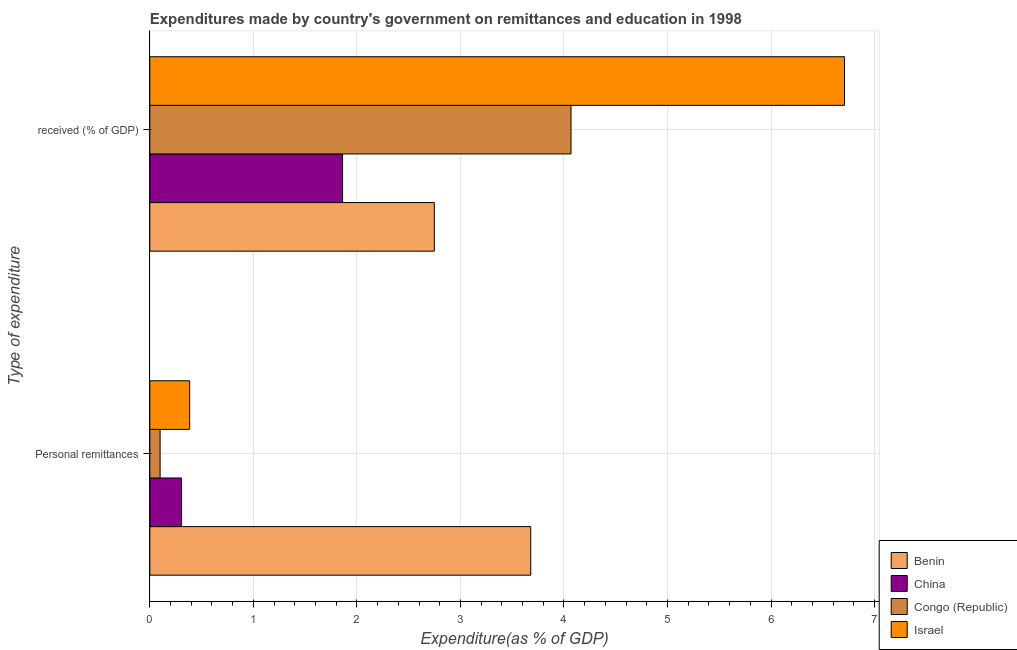How many groups of bars are there?
Ensure brevity in your answer.  2. How many bars are there on the 2nd tick from the top?
Your response must be concise. 4. How many bars are there on the 2nd tick from the bottom?
Provide a short and direct response. 4. What is the label of the 1st group of bars from the top?
Your response must be concise.  received (% of GDP). What is the expenditure in personal remittances in China?
Make the answer very short. 0.31. Across all countries, what is the maximum expenditure in education?
Your answer should be very brief. 6.71. Across all countries, what is the minimum expenditure in personal remittances?
Your answer should be compact. 0.1. In which country was the expenditure in personal remittances minimum?
Ensure brevity in your answer.  Congo (Republic). What is the total expenditure in education in the graph?
Offer a terse response. 15.39. What is the difference between the expenditure in personal remittances in Congo (Republic) and that in Benin?
Provide a succinct answer. -3.58. What is the difference between the expenditure in personal remittances in Congo (Republic) and the expenditure in education in China?
Offer a terse response. -1.76. What is the average expenditure in education per country?
Your answer should be compact. 3.85. What is the difference between the expenditure in personal remittances and expenditure in education in Benin?
Give a very brief answer. 0.93. In how many countries, is the expenditure in personal remittances greater than 1 %?
Keep it short and to the point. 1. What is the ratio of the expenditure in education in China to that in Benin?
Provide a succinct answer. 0.68. What does the 3rd bar from the bottom in  received (% of GDP) represents?
Keep it short and to the point. Congo (Republic). How many bars are there?
Provide a succinct answer. 8. Are all the bars in the graph horizontal?
Offer a very short reply. Yes. Does the graph contain grids?
Your answer should be compact. Yes. Where does the legend appear in the graph?
Your answer should be very brief. Bottom right. How many legend labels are there?
Your answer should be very brief. 4. How are the legend labels stacked?
Provide a short and direct response. Vertical. What is the title of the graph?
Make the answer very short. Expenditures made by country's government on remittances and education in 1998. What is the label or title of the X-axis?
Your answer should be very brief. Expenditure(as % of GDP). What is the label or title of the Y-axis?
Your answer should be very brief. Type of expenditure. What is the Expenditure(as % of GDP) of Benin in Personal remittances?
Offer a terse response. 3.68. What is the Expenditure(as % of GDP) in China in Personal remittances?
Offer a very short reply. 0.31. What is the Expenditure(as % of GDP) of Congo (Republic) in Personal remittances?
Keep it short and to the point. 0.1. What is the Expenditure(as % of GDP) of Israel in Personal remittances?
Make the answer very short. 0.38. What is the Expenditure(as % of GDP) of Benin in  received (% of GDP)?
Keep it short and to the point. 2.75. What is the Expenditure(as % of GDP) of China in  received (% of GDP)?
Ensure brevity in your answer.  1.86. What is the Expenditure(as % of GDP) of Congo (Republic) in  received (% of GDP)?
Keep it short and to the point. 4.07. What is the Expenditure(as % of GDP) in Israel in  received (% of GDP)?
Your response must be concise. 6.71. Across all Type of expenditure, what is the maximum Expenditure(as % of GDP) in Benin?
Provide a succinct answer. 3.68. Across all Type of expenditure, what is the maximum Expenditure(as % of GDP) in China?
Provide a short and direct response. 1.86. Across all Type of expenditure, what is the maximum Expenditure(as % of GDP) in Congo (Republic)?
Your response must be concise. 4.07. Across all Type of expenditure, what is the maximum Expenditure(as % of GDP) in Israel?
Offer a terse response. 6.71. Across all Type of expenditure, what is the minimum Expenditure(as % of GDP) of Benin?
Provide a succinct answer. 2.75. Across all Type of expenditure, what is the minimum Expenditure(as % of GDP) of China?
Make the answer very short. 0.31. Across all Type of expenditure, what is the minimum Expenditure(as % of GDP) of Congo (Republic)?
Your answer should be very brief. 0.1. Across all Type of expenditure, what is the minimum Expenditure(as % of GDP) in Israel?
Ensure brevity in your answer.  0.38. What is the total Expenditure(as % of GDP) of Benin in the graph?
Offer a very short reply. 6.43. What is the total Expenditure(as % of GDP) of China in the graph?
Provide a short and direct response. 2.17. What is the total Expenditure(as % of GDP) in Congo (Republic) in the graph?
Your response must be concise. 4.17. What is the total Expenditure(as % of GDP) of Israel in the graph?
Provide a succinct answer. 7.09. What is the difference between the Expenditure(as % of GDP) in Benin in Personal remittances and that in  received (% of GDP)?
Keep it short and to the point. 0.93. What is the difference between the Expenditure(as % of GDP) of China in Personal remittances and that in  received (% of GDP)?
Provide a succinct answer. -1.56. What is the difference between the Expenditure(as % of GDP) of Congo (Republic) in Personal remittances and that in  received (% of GDP)?
Your answer should be compact. -3.97. What is the difference between the Expenditure(as % of GDP) in Israel in Personal remittances and that in  received (% of GDP)?
Your answer should be compact. -6.32. What is the difference between the Expenditure(as % of GDP) of Benin in Personal remittances and the Expenditure(as % of GDP) of China in  received (% of GDP)?
Your response must be concise. 1.82. What is the difference between the Expenditure(as % of GDP) of Benin in Personal remittances and the Expenditure(as % of GDP) of Congo (Republic) in  received (% of GDP)?
Make the answer very short. -0.39. What is the difference between the Expenditure(as % of GDP) of Benin in Personal remittances and the Expenditure(as % of GDP) of Israel in  received (% of GDP)?
Your answer should be very brief. -3.03. What is the difference between the Expenditure(as % of GDP) of China in Personal remittances and the Expenditure(as % of GDP) of Congo (Republic) in  received (% of GDP)?
Your answer should be compact. -3.76. What is the difference between the Expenditure(as % of GDP) of China in Personal remittances and the Expenditure(as % of GDP) of Israel in  received (% of GDP)?
Keep it short and to the point. -6.4. What is the difference between the Expenditure(as % of GDP) of Congo (Republic) in Personal remittances and the Expenditure(as % of GDP) of Israel in  received (% of GDP)?
Your answer should be very brief. -6.61. What is the average Expenditure(as % of GDP) in Benin per Type of expenditure?
Offer a terse response. 3.21. What is the average Expenditure(as % of GDP) of China per Type of expenditure?
Provide a succinct answer. 1.08. What is the average Expenditure(as % of GDP) in Congo (Republic) per Type of expenditure?
Ensure brevity in your answer.  2.08. What is the average Expenditure(as % of GDP) in Israel per Type of expenditure?
Offer a terse response. 3.55. What is the difference between the Expenditure(as % of GDP) in Benin and Expenditure(as % of GDP) in China in Personal remittances?
Make the answer very short. 3.37. What is the difference between the Expenditure(as % of GDP) in Benin and Expenditure(as % of GDP) in Congo (Republic) in Personal remittances?
Your answer should be very brief. 3.58. What is the difference between the Expenditure(as % of GDP) in Benin and Expenditure(as % of GDP) in Israel in Personal remittances?
Give a very brief answer. 3.29. What is the difference between the Expenditure(as % of GDP) of China and Expenditure(as % of GDP) of Congo (Republic) in Personal remittances?
Your answer should be very brief. 0.21. What is the difference between the Expenditure(as % of GDP) in China and Expenditure(as % of GDP) in Israel in Personal remittances?
Provide a short and direct response. -0.08. What is the difference between the Expenditure(as % of GDP) in Congo (Republic) and Expenditure(as % of GDP) in Israel in Personal remittances?
Keep it short and to the point. -0.29. What is the difference between the Expenditure(as % of GDP) in Benin and Expenditure(as % of GDP) in China in  received (% of GDP)?
Ensure brevity in your answer.  0.89. What is the difference between the Expenditure(as % of GDP) of Benin and Expenditure(as % of GDP) of Congo (Republic) in  received (% of GDP)?
Provide a short and direct response. -1.32. What is the difference between the Expenditure(as % of GDP) of Benin and Expenditure(as % of GDP) of Israel in  received (% of GDP)?
Make the answer very short. -3.96. What is the difference between the Expenditure(as % of GDP) of China and Expenditure(as % of GDP) of Congo (Republic) in  received (% of GDP)?
Offer a very short reply. -2.21. What is the difference between the Expenditure(as % of GDP) of China and Expenditure(as % of GDP) of Israel in  received (% of GDP)?
Provide a succinct answer. -4.85. What is the difference between the Expenditure(as % of GDP) of Congo (Republic) and Expenditure(as % of GDP) of Israel in  received (% of GDP)?
Your answer should be very brief. -2.64. What is the ratio of the Expenditure(as % of GDP) in Benin in Personal remittances to that in  received (% of GDP)?
Provide a succinct answer. 1.34. What is the ratio of the Expenditure(as % of GDP) in China in Personal remittances to that in  received (% of GDP)?
Offer a terse response. 0.16. What is the ratio of the Expenditure(as % of GDP) in Congo (Republic) in Personal remittances to that in  received (% of GDP)?
Offer a very short reply. 0.02. What is the ratio of the Expenditure(as % of GDP) of Israel in Personal remittances to that in  received (% of GDP)?
Provide a short and direct response. 0.06. What is the difference between the highest and the second highest Expenditure(as % of GDP) in Benin?
Ensure brevity in your answer.  0.93. What is the difference between the highest and the second highest Expenditure(as % of GDP) in China?
Make the answer very short. 1.56. What is the difference between the highest and the second highest Expenditure(as % of GDP) in Congo (Republic)?
Keep it short and to the point. 3.97. What is the difference between the highest and the second highest Expenditure(as % of GDP) of Israel?
Your response must be concise. 6.32. What is the difference between the highest and the lowest Expenditure(as % of GDP) in Benin?
Provide a succinct answer. 0.93. What is the difference between the highest and the lowest Expenditure(as % of GDP) in China?
Provide a short and direct response. 1.56. What is the difference between the highest and the lowest Expenditure(as % of GDP) of Congo (Republic)?
Make the answer very short. 3.97. What is the difference between the highest and the lowest Expenditure(as % of GDP) in Israel?
Provide a short and direct response. 6.32. 